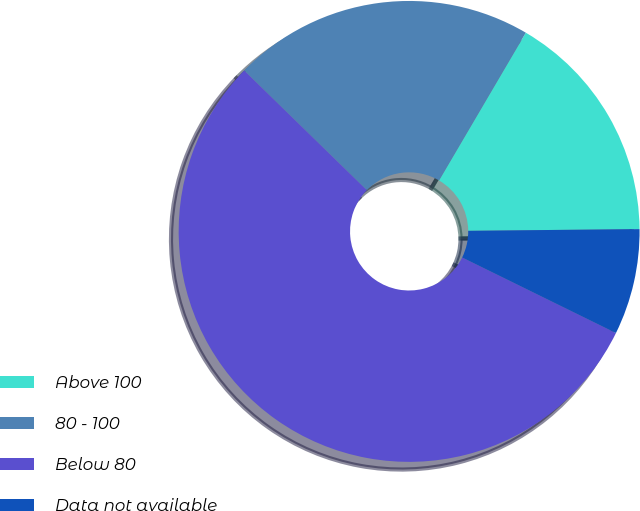Convert chart. <chart><loc_0><loc_0><loc_500><loc_500><pie_chart><fcel>Above 100<fcel>80 - 100<fcel>Below 80<fcel>Data not available<nl><fcel>16.39%<fcel>21.15%<fcel>55.04%<fcel>7.43%<nl></chart> 